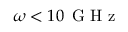<formula> <loc_0><loc_0><loc_500><loc_500>\omega < 1 0 \, G H z</formula> 